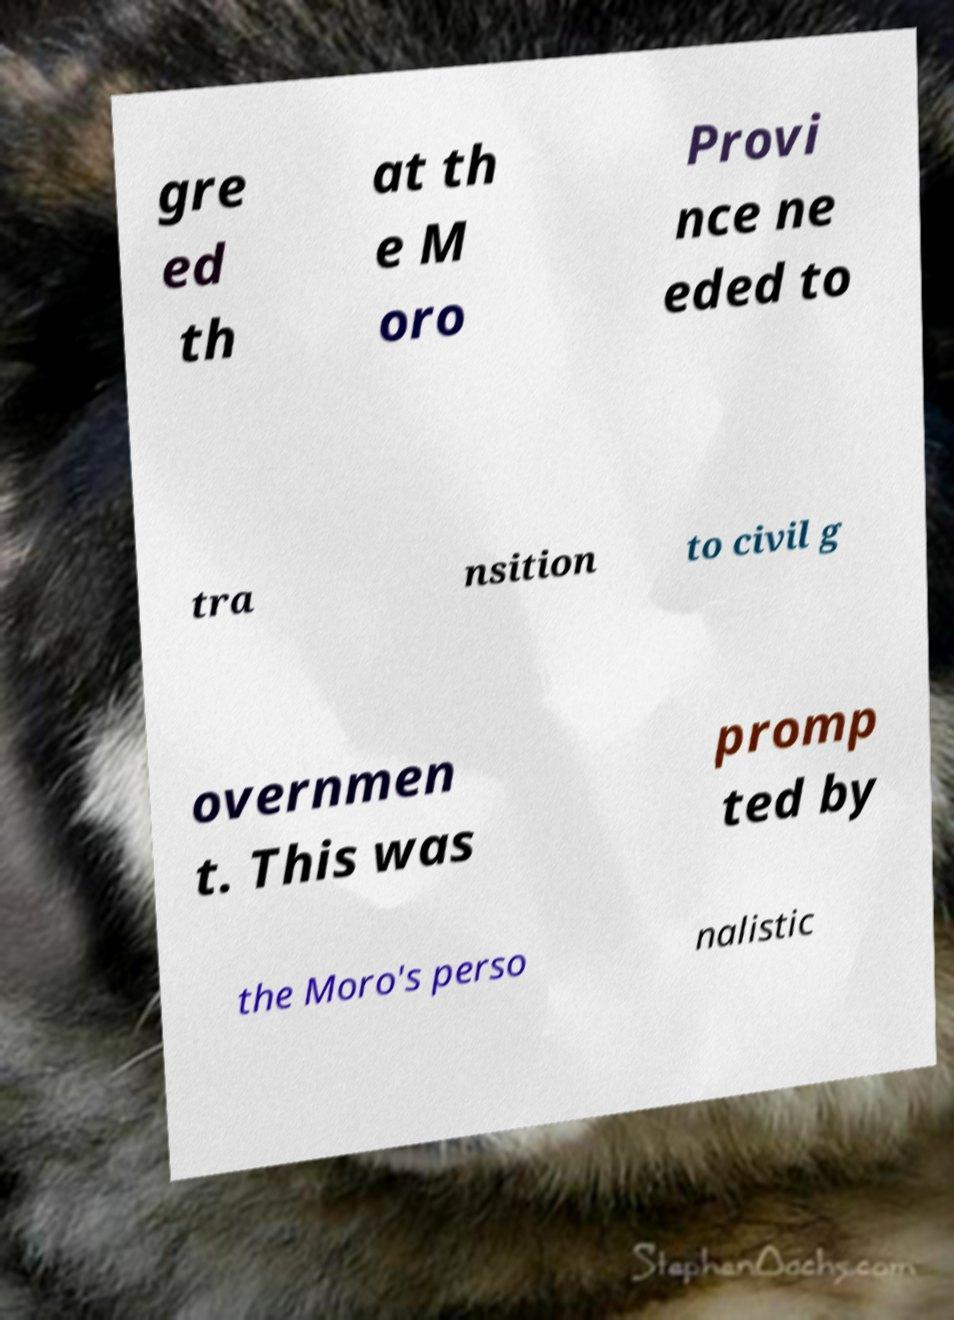What messages or text are displayed in this image? I need them in a readable, typed format. gre ed th at th e M oro Provi nce ne eded to tra nsition to civil g overnmen t. This was promp ted by the Moro's perso nalistic 